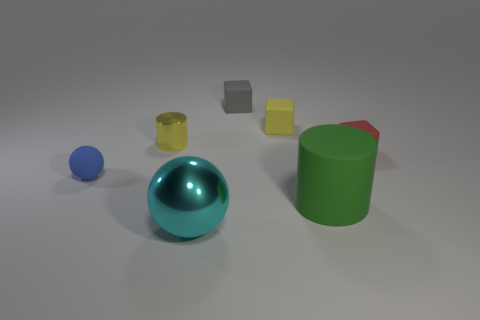Add 1 small red balls. How many objects exist? 8 Subtract all blue spheres. How many spheres are left? 1 Subtract all gray matte cubes. How many cubes are left? 2 Subtract 0 purple spheres. How many objects are left? 7 Subtract all cylinders. How many objects are left? 5 Subtract 3 blocks. How many blocks are left? 0 Subtract all yellow spheres. Subtract all gray cubes. How many spheres are left? 2 Subtract all brown cylinders. How many purple balls are left? 0 Subtract all purple spheres. Subtract all gray rubber objects. How many objects are left? 6 Add 4 rubber spheres. How many rubber spheres are left? 5 